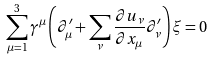<formula> <loc_0><loc_0><loc_500><loc_500>\sum _ { \mu = 1 } ^ { 3 } \gamma ^ { \mu } \left ( \partial _ { \mu } ^ { \prime } + \sum _ { \nu } \frac { \partial u _ { \nu } } { \partial x _ { \mu } } \partial _ { \nu } ^ { \prime } \right ) \xi = 0</formula> 